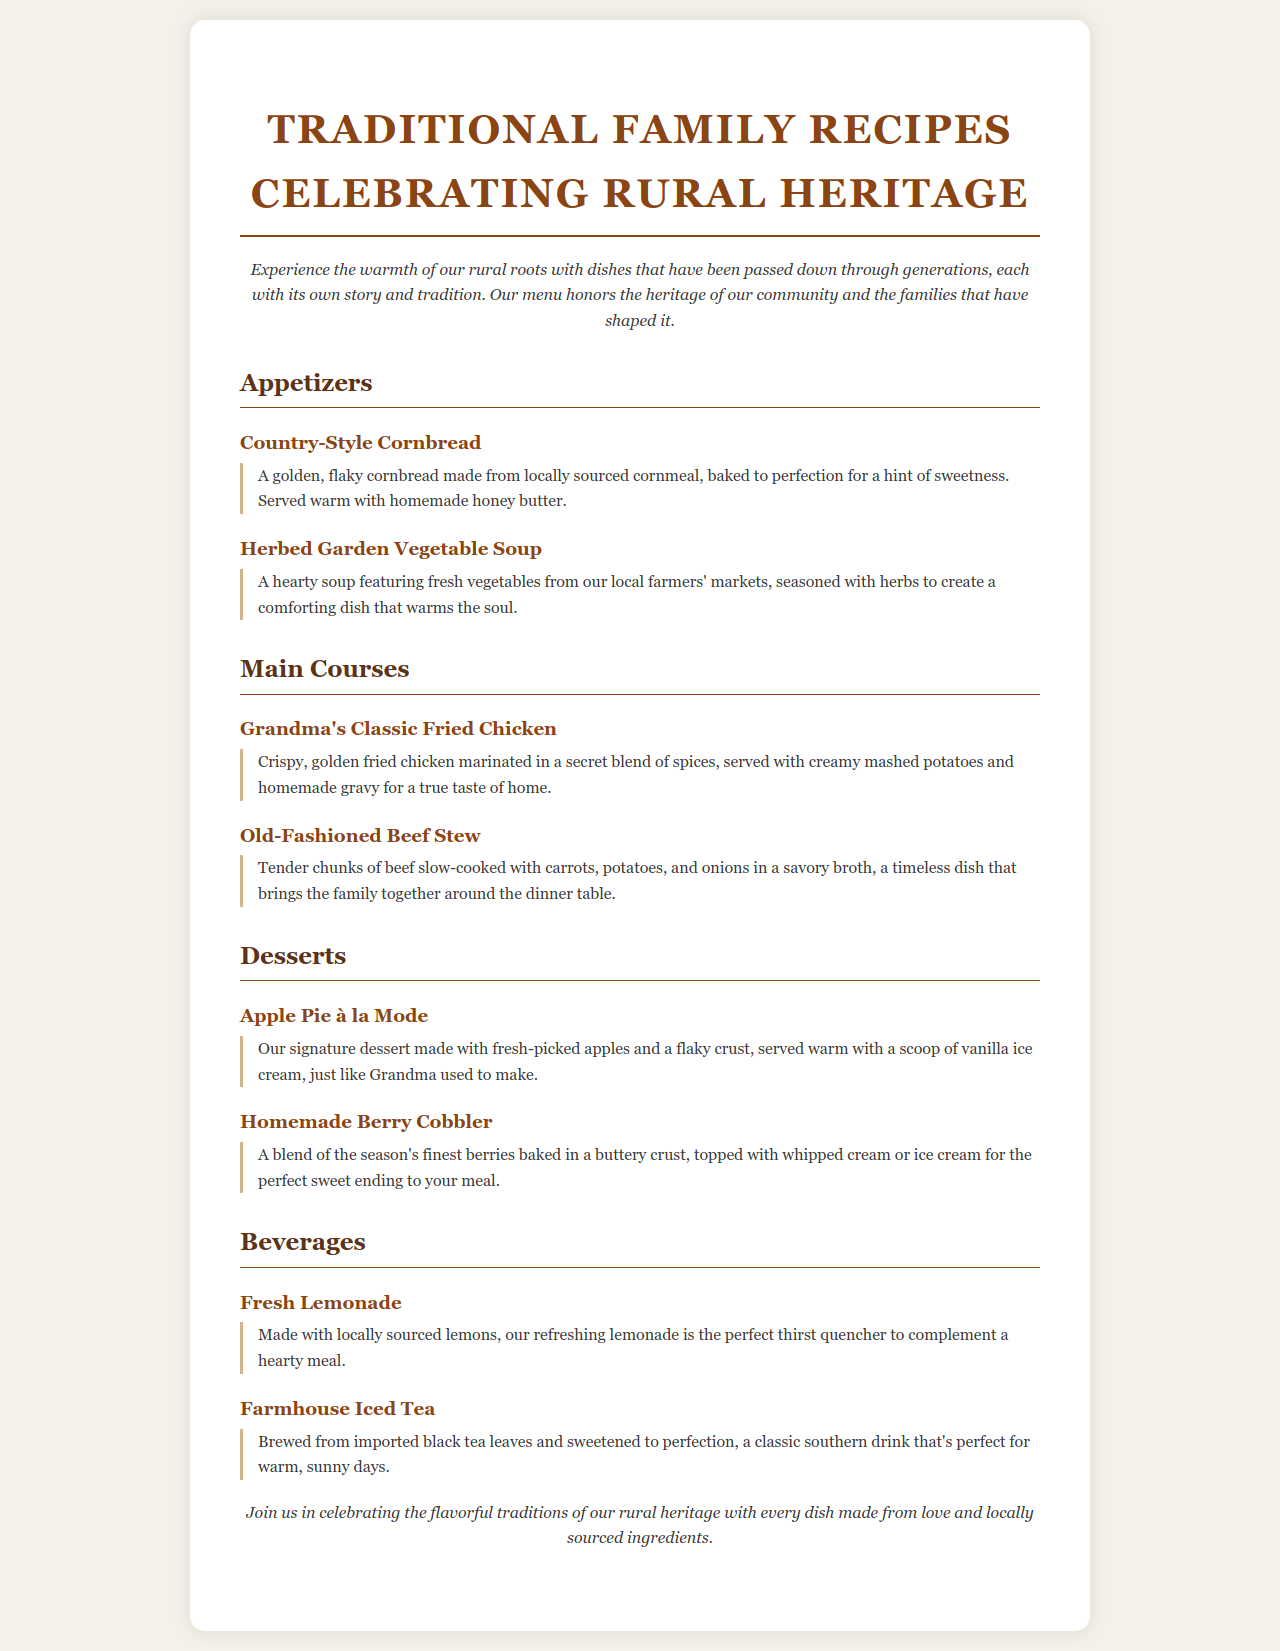What is the title of the menu? The title is prominently displayed at the top of the document.
Answer: Traditional Family Recipes Celebrating Rural Heritage What type of dish is Grandma's Classic Fried Chicken? This dish is categorized under the 'Main Courses' section of the menu.
Answer: Main Course What is served with the Homemade Berry Cobbler? The dessert description includes what accompanies it.
Answer: Whipped cream or ice cream Which beverage is made with locally sourced lemons? The beverages section specifies the ingredients for each drink.
Answer: Fresh Lemonade How many appetizers are listed on the menu? The appetizers section contains two items listed under it.
Answer: 2 What ingredient is used in the Old-Fashioned Beef Stew? The stew description includes what main ingredients it contains.
Answer: Beef What is the color scheme mainly used for headings? The colors of headings can be seen in the various sections.
Answer: Dark brown Which dessert uses fresh-picked apples? The desserts section clearly mentions this ingredient in its description.
Answer: Apple Pie à la Mode 